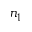Convert formula to latex. <formula><loc_0><loc_0><loc_500><loc_500>n _ { 1 }</formula> 